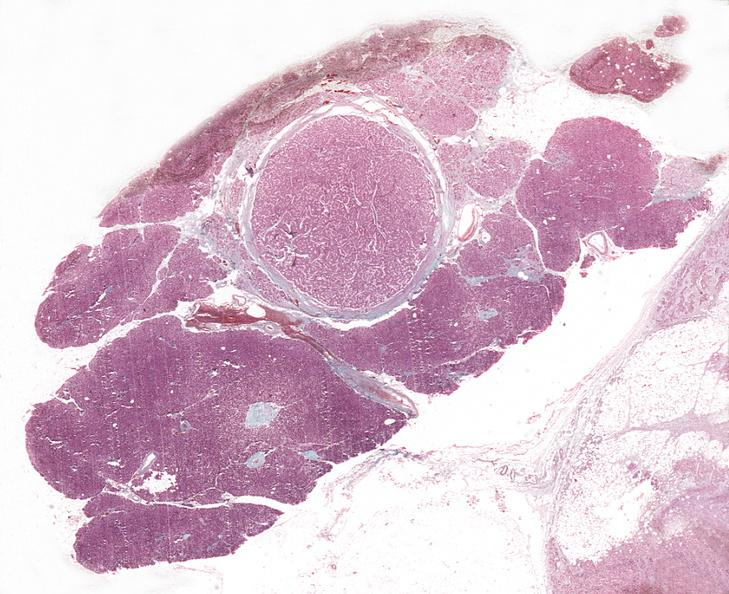does this image show islet cell adenoma, non-functional?
Answer the question using a single word or phrase. Yes 